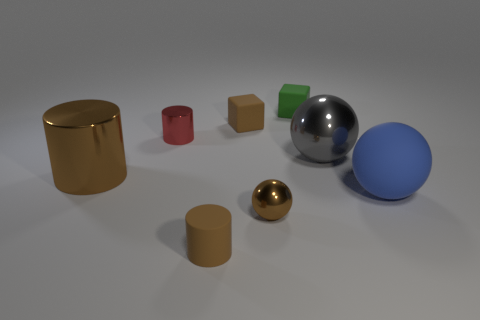What color is the other large metal object that is the same shape as the blue thing?
Your answer should be very brief. Gray. There is a rubber object that is behind the large blue ball and in front of the small green object; what size is it?
Make the answer very short. Small. There is a brown matte thing that is behind the blue object; is its shape the same as the green matte thing behind the red metallic cylinder?
Give a very brief answer. Yes. There is a big object that is the same color as the small metal sphere; what shape is it?
Provide a short and direct response. Cylinder. What number of large green cylinders have the same material as the green block?
Offer a very short reply. 0. There is a brown object that is both to the right of the red metallic cylinder and behind the blue matte thing; what shape is it?
Offer a terse response. Cube. Do the small object left of the brown rubber cylinder and the green thing have the same material?
Provide a short and direct response. No. The metallic sphere that is the same size as the green matte cube is what color?
Offer a very short reply. Brown. Is there a cube that has the same color as the tiny rubber cylinder?
Offer a terse response. Yes. There is a blue sphere that is the same material as the small green block; what size is it?
Make the answer very short. Large. 